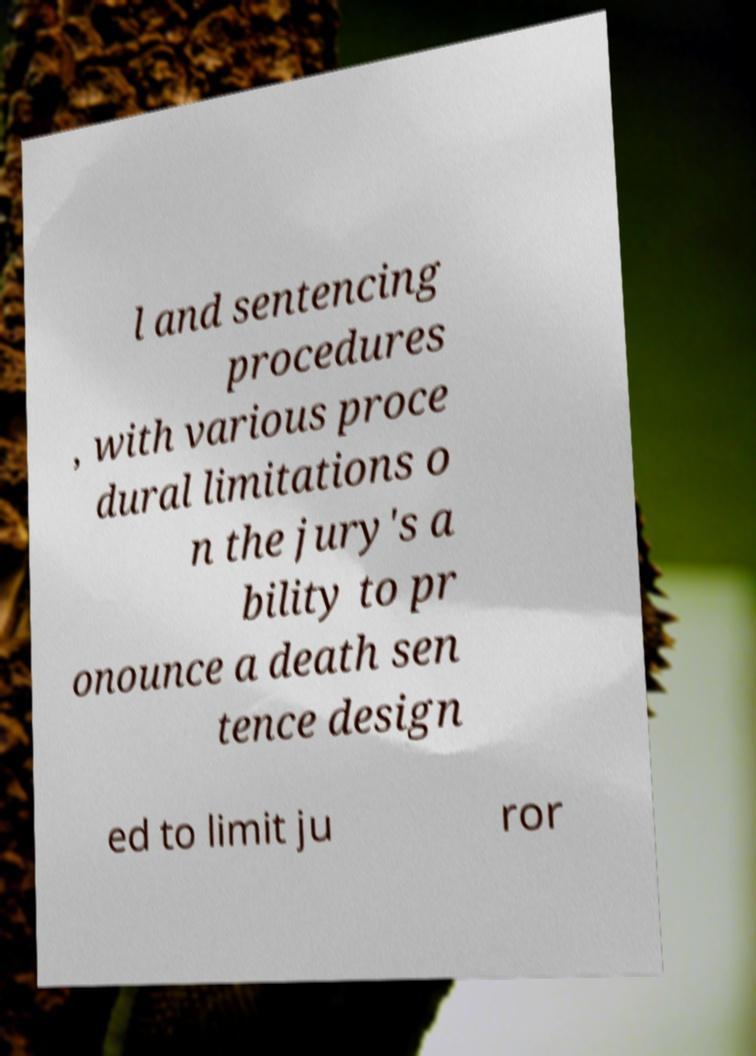There's text embedded in this image that I need extracted. Can you transcribe it verbatim? l and sentencing procedures , with various proce dural limitations o n the jury's a bility to pr onounce a death sen tence design ed to limit ju ror 